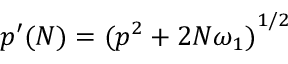Convert formula to latex. <formula><loc_0><loc_0><loc_500><loc_500>{ p ^ { \prime } } ( N ) = { ( p ^ { 2 } + 2 N \omega _ { 1 } ) } ^ { 1 / 2 }</formula> 